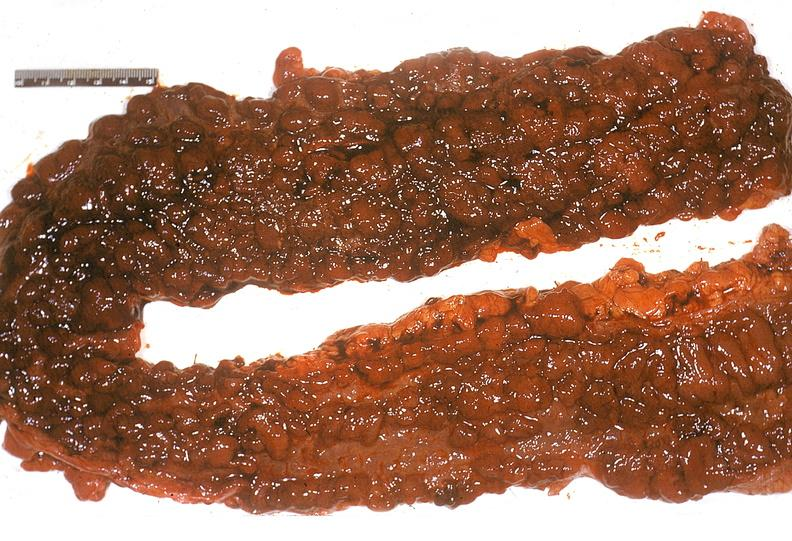s gastrointestinal present?
Answer the question using a single word or phrase. Yes 